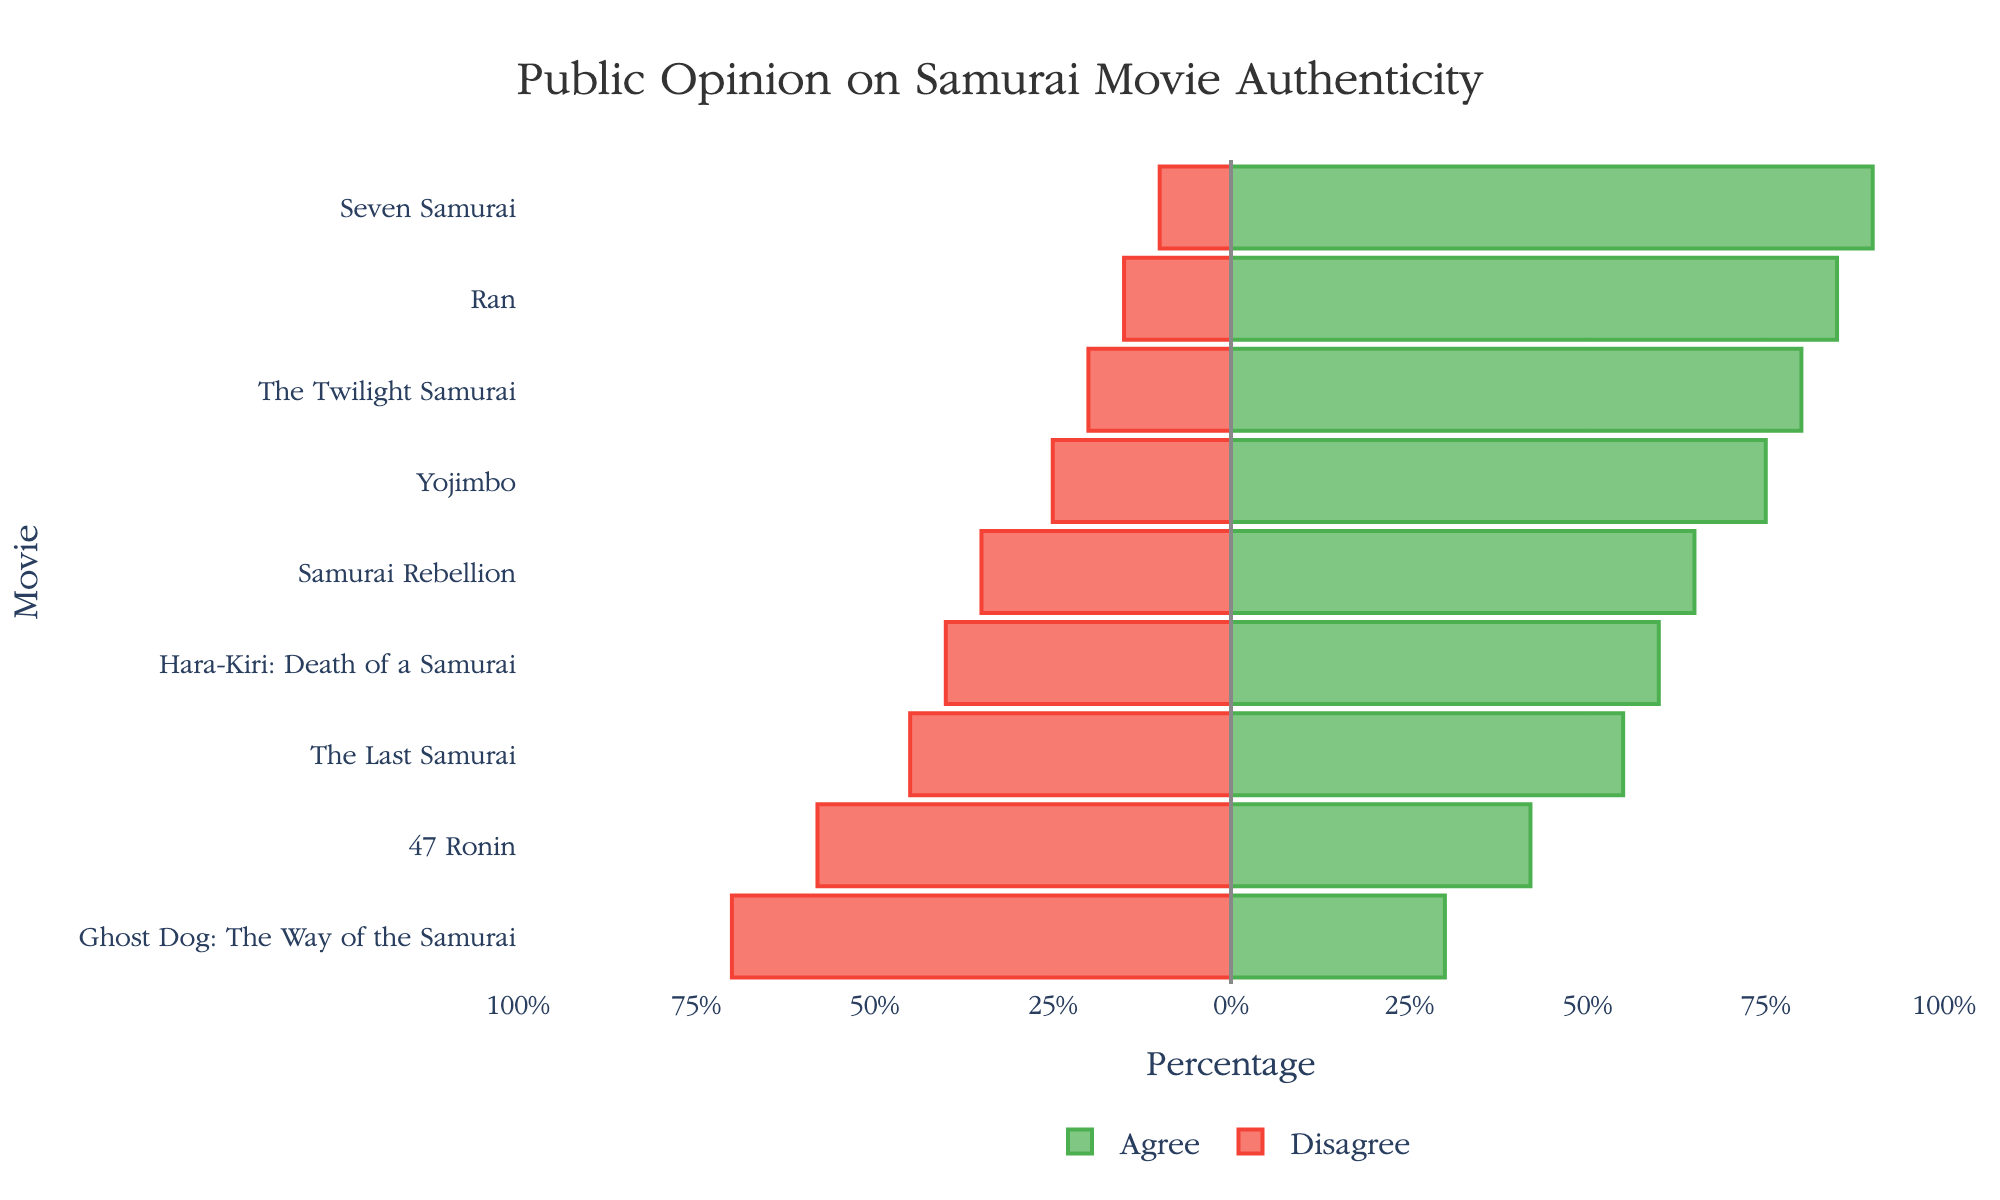What movie received the highest percentage of agreement on its authenticity? To find the movie with the highest percentage of agreement, look for the longest green bar extending to the right. "Seven Samurai" has the longest green bar, indicating 90% agreement.
Answer: "Seven Samurai" Which movie has the highest percentage of disagreement? Locate the longest red bar extending to the left. "Ghost Dog: The Way of the Samurai" has the longest red bar at 70% disagreement.
Answer: "Ghost Dog: The Way of the Samurai" How many movies have more than 50% disagreement? Identify bars where the red section exceeds the midpoint, representing more than 50%. These movies are "47 Ronin" and "Ghost Dog: The Way of the Samurai".
Answer: 2 What is the average percentage of agreement for "Ran" and "Yojimbo"? Add the agreement percentages for "Ran" (85%) and "Yojimbo" (75%), then divide by 2. (85 + 75) / 2 = 80
Answer: 80% Which movie has exactly 60% agreement? Look for the green bar labeled with 60%. "Hara-Kiri: Death of a Samurai" has exactly 60% agreement.
Answer: "Hara-Kiri: Death of a Samurai" Compare the agreement percentages of "The Last Samurai" and "Samurai Rebellion". Which is higher? Identify the green bars for "The Last Samurai" (55%) and "Samurai Rebellion" (65%). "Samurai Rebellion" has a higher agreement percentage than "The Last Samurai".
Answer: "Samurai Rebellion" What is the median percentage of agreement among all the movies? Sort the agreement percentages: 30%, 42%, 55%, 60%, 65%, 75%, 80%, 85%, 90%. The median is the middle value, which is 65%.
Answer: 65% By how much does the agreement percentage for "Seven Samurai" exceed that of "The Last Samurai"? Subtract the agreement percentage of "The Last Samurai" (55%) from that of "Seven Samurai" (90%). 90 - 55 = 35
Answer: 35% Are there any movies where the percentage of disagreement is less than 20%? Look for red bars less than 20%. "Seven Samurai" (10%), "Ran" (15%), and "The Twilight Samurai" (20%) fit this criterion.
Answer: Yes What is the total percentage of agreement for "Hara-Kiri: Death of a Samurai" and "The Twilight Samurai" combined? Add the agreement percentages for "Hara-Kiri: Death of a Samurai" (60%) and "The Twilight Samurai" (80%). 60 + 80 = 140
Answer: 140% 